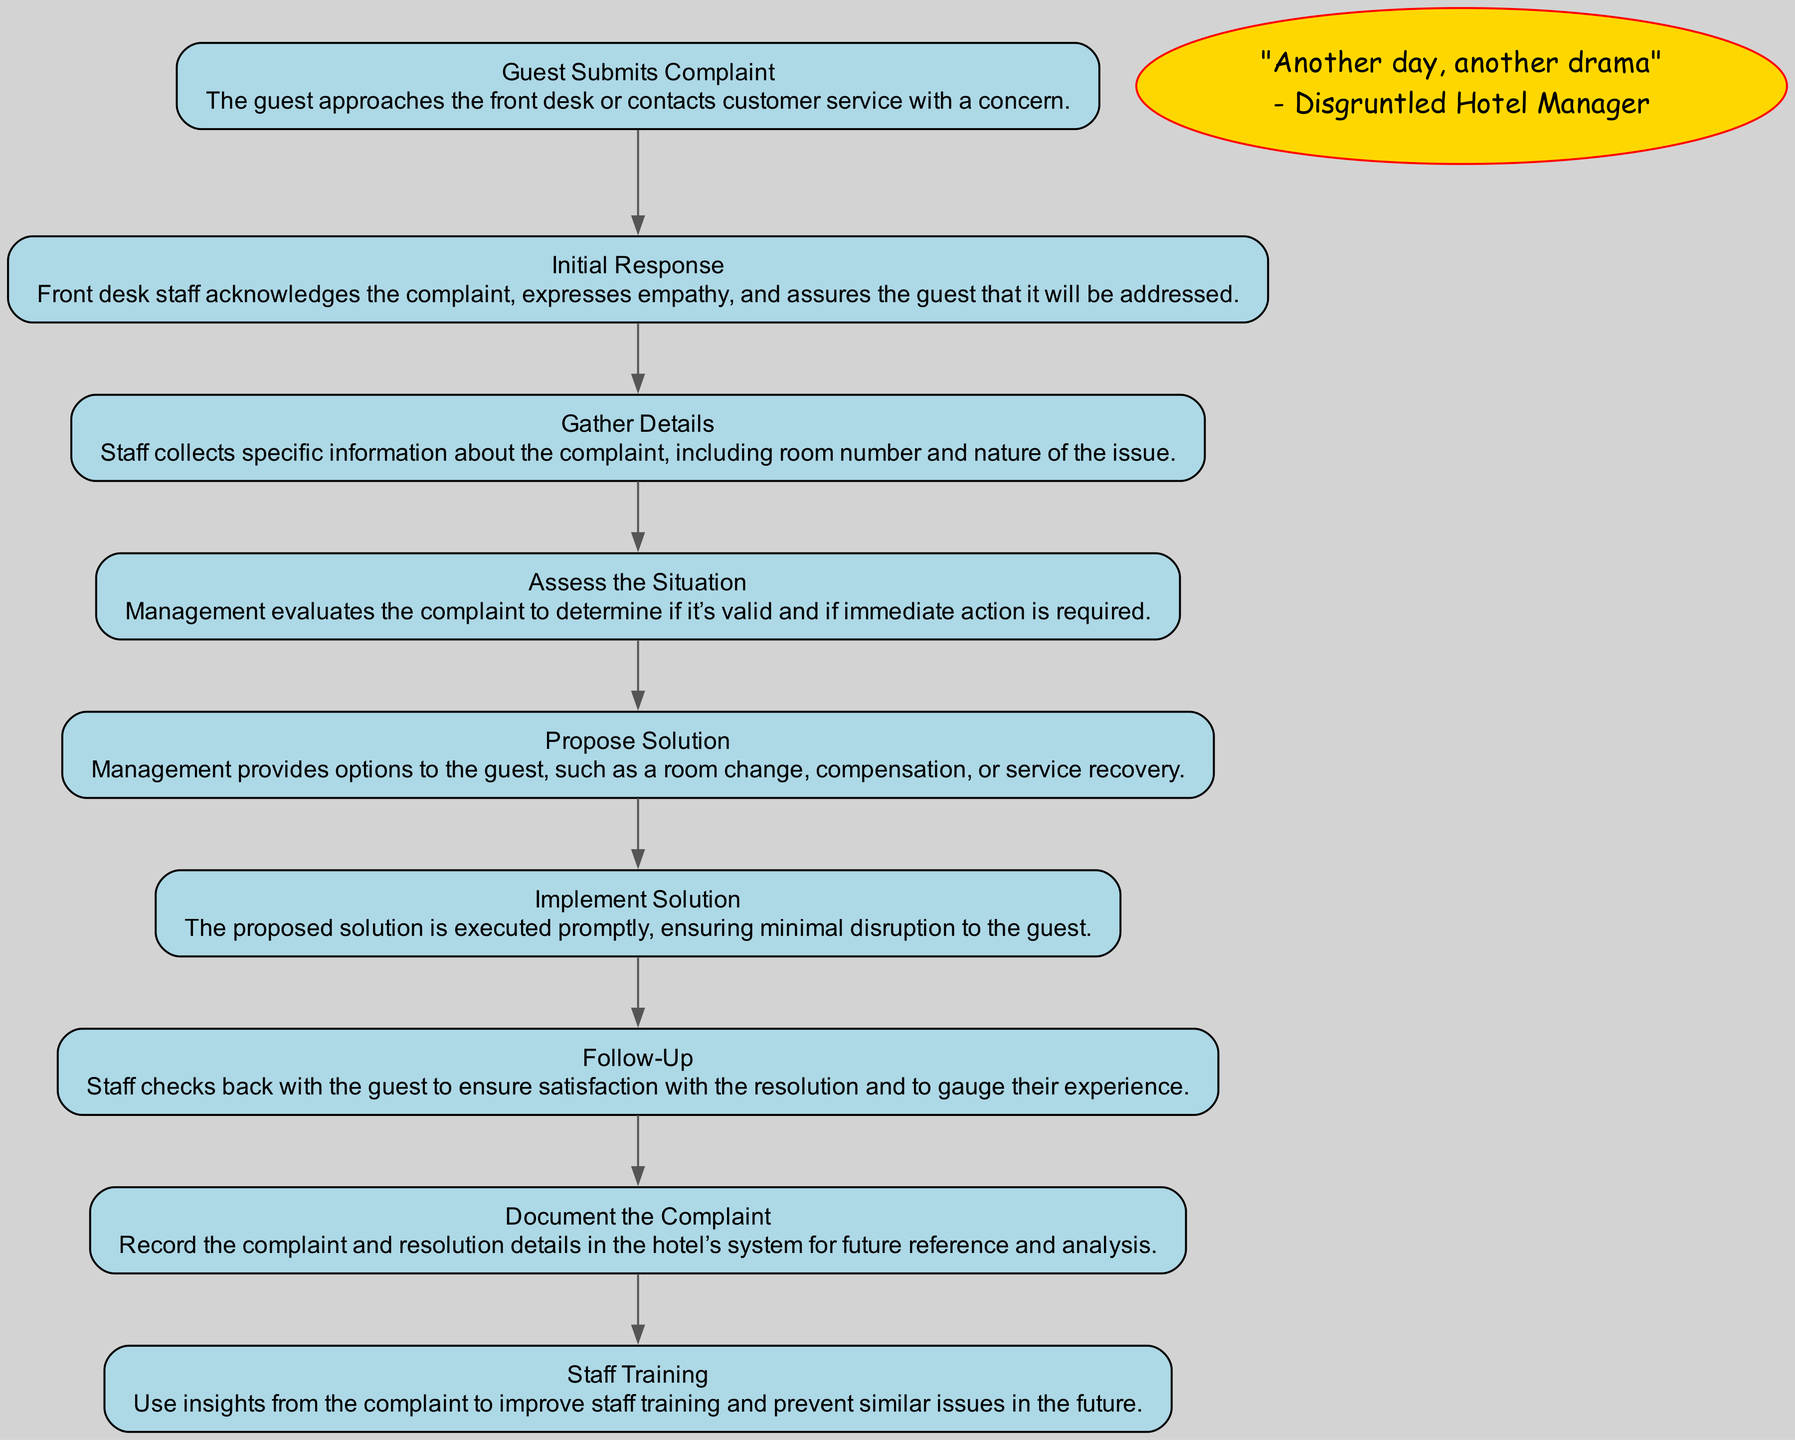What is the first step in the Guest Complaint Resolution Process? The first step is indicated by the initial node in the diagram, which states "Guest Submits Complaint." This is where a guest approaches the hotel staff with their concern.
Answer: Guest Submits Complaint How many total steps are in the process? By counting the nodes in the diagram from the first step to the last, I find there are nine distinct steps involved in the resolution process.
Answer: Nine Which step follows "Initial Response"? From the flow of the diagram, the step that follows "Initial Response" is "Gather Details," as each node connects sequentially.
Answer: Gather Details What does the "Follow-Up" step entail? The "Follow-Up" step involves staff checking back with the guest to ensure satisfaction with the resolution provided and to gauge the guest's experience.
Answer: Staff checks back with the guest What action does management take after assessing the situation? After assessing the situation, management provides options to the guest in the "Propose Solution" step, which involves suggesting remedial actions they can take.
Answer: Propose Solution Which process step includes recording details for future reference? The step for recording details in the hotel’s system is "Document the Complaint." This is crucial for maintaining a record of issues and resolutions for future analysis.
Answer: Document the Complaint What type of improvements does "Staff Training" aim for? "Staff Training" aims at improving staff performance and preventing similar complaints by utilizing insights gained from the previous complaints.
Answer: Improve staff training Which step is crucial for determining if immediate action is required? The step where management evaluates the complaint to determine if immediate action is needed is "Assess the Situation." This assessment is crucial for timely intervention.
Answer: Assess the Situation What is the relationship between "Propose Solution" and "Implement Solution"? The relationship is sequential; after management proposes a solution, the next step is to actually execute or implement that proposed solution, thus confirming the effectiveness of the suggestion.
Answer: Sequential relationship 